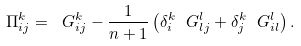<formula> <loc_0><loc_0><loc_500><loc_500>\Pi _ { i j } ^ { k } = \ G _ { i j } ^ { k } - \frac { 1 } { n + 1 } \left ( \delta _ { i } ^ { k } \ G _ { l j } ^ { l } + \delta _ { j } ^ { k } \ G _ { i l } ^ { l } \right ) .</formula> 